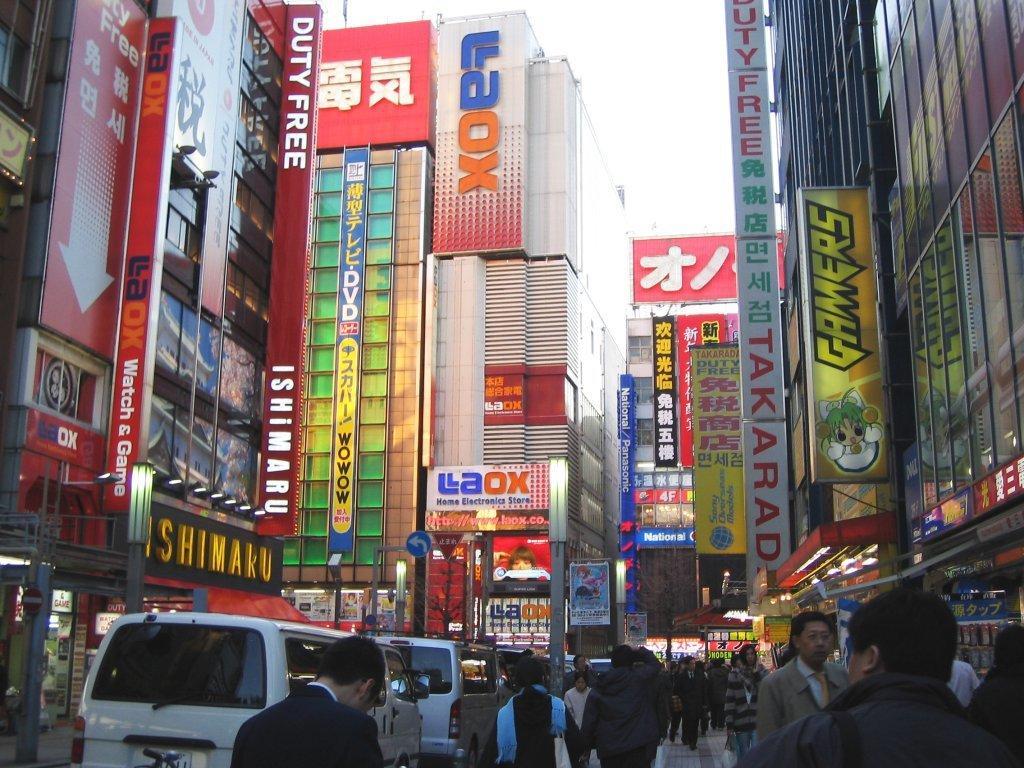Could you give a brief overview of what you see in this image? In this image at the bottom we can see vehicles and few persons. In the background there are buildings, windows, hoardings, lights, objects and the sky. 